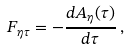Convert formula to latex. <formula><loc_0><loc_0><loc_500><loc_500>F _ { \eta \tau } = - \frac { d A _ { \eta } ( \tau ) } { d \tau } \, ,</formula> 